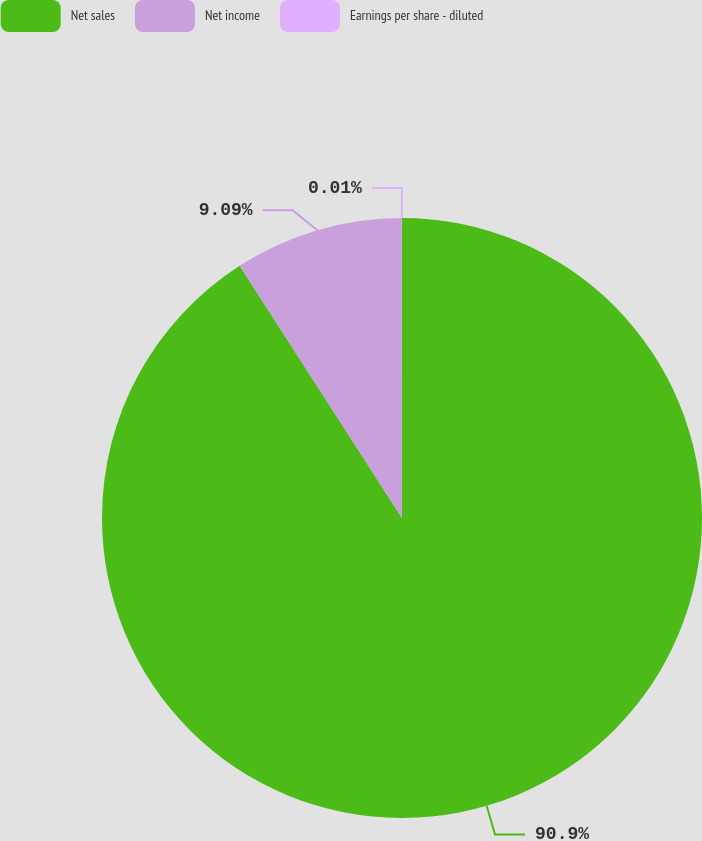Convert chart. <chart><loc_0><loc_0><loc_500><loc_500><pie_chart><fcel>Net sales<fcel>Net income<fcel>Earnings per share - diluted<nl><fcel>90.9%<fcel>9.09%<fcel>0.01%<nl></chart> 